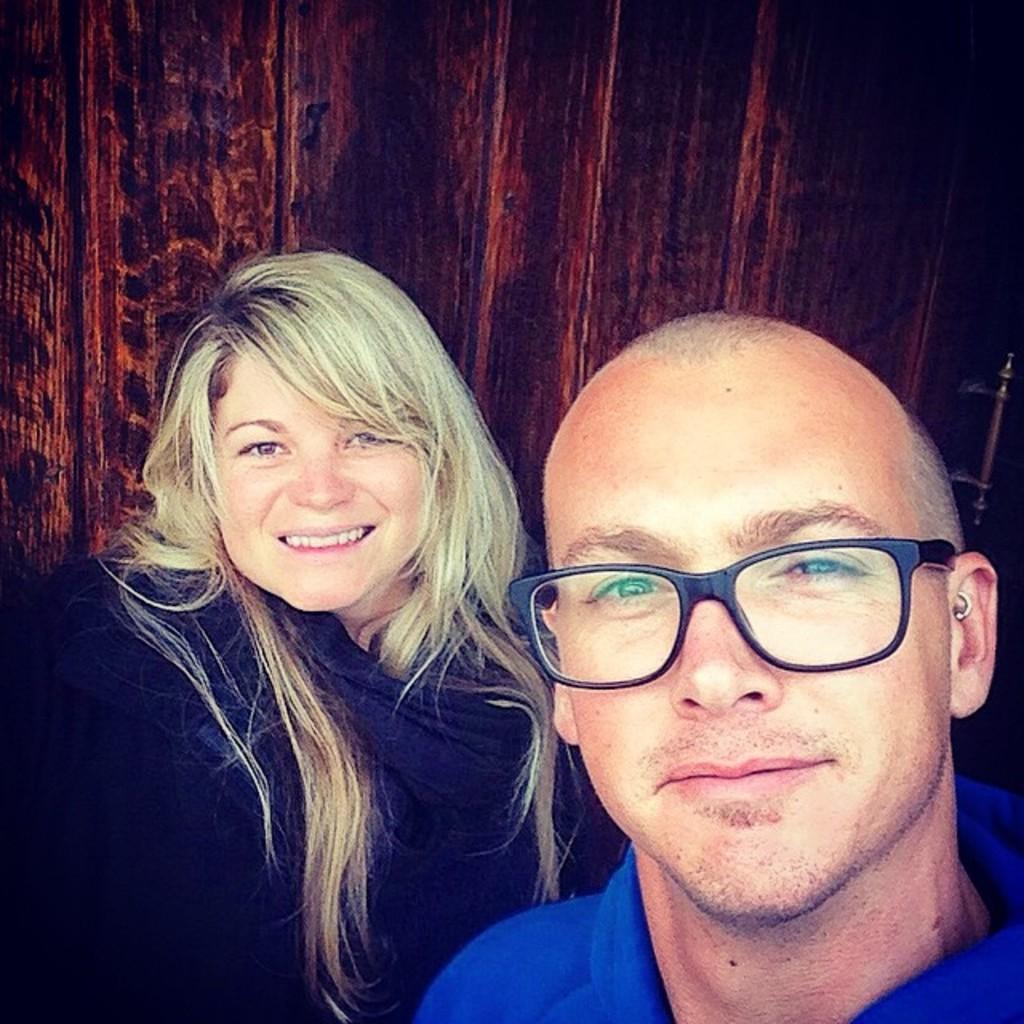How would you summarize this image in a sentence or two? This image is taken indoors. In the background there is a door. In the middle of the image there is a man and a woman and they are with smiling faces. 